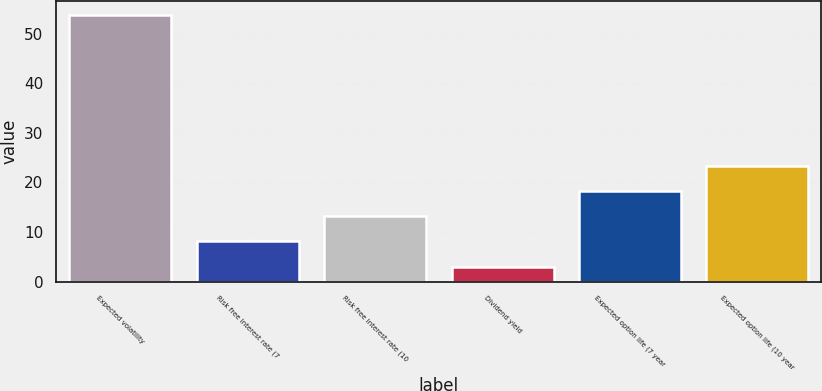<chart> <loc_0><loc_0><loc_500><loc_500><bar_chart><fcel>Expected volatility<fcel>Risk free interest rate (7<fcel>Risk free interest rate (10<fcel>Dividend yield<fcel>Expected option life (7 year<fcel>Expected option life (10 year<nl><fcel>53.87<fcel>8.12<fcel>13.2<fcel>3.04<fcel>18.28<fcel>23.36<nl></chart> 